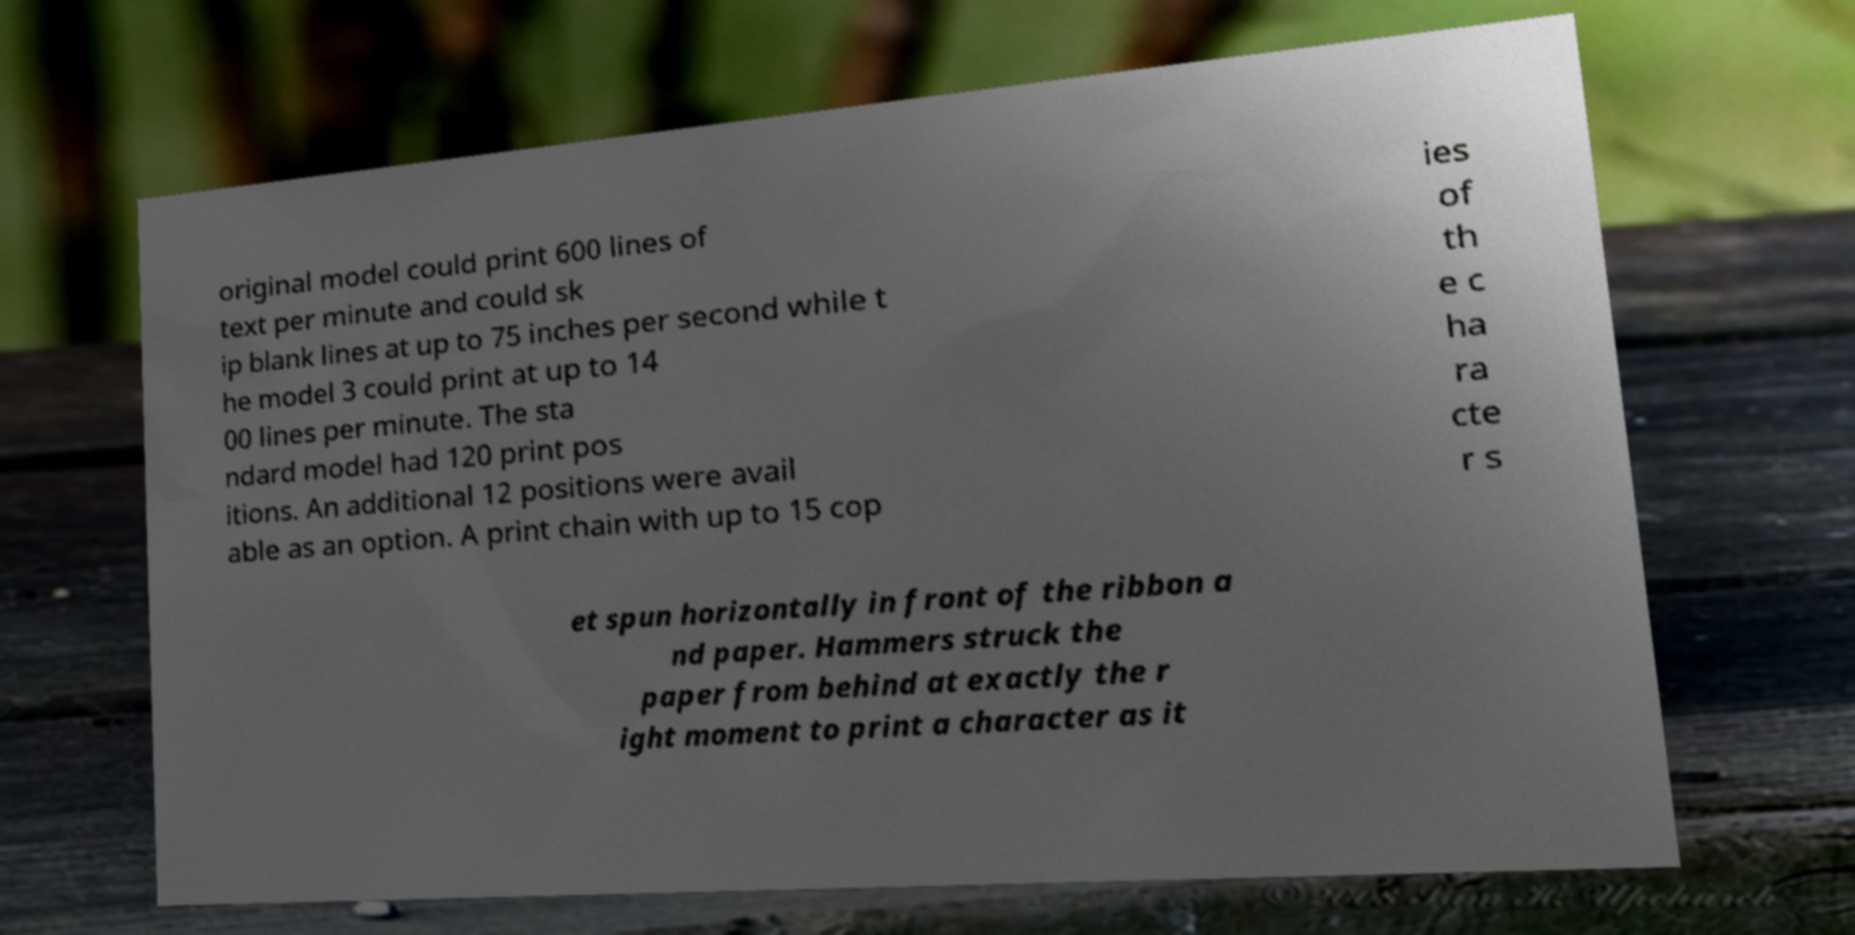For documentation purposes, I need the text within this image transcribed. Could you provide that? original model could print 600 lines of text per minute and could sk ip blank lines at up to 75 inches per second while t he model 3 could print at up to 14 00 lines per minute. The sta ndard model had 120 print pos itions. An additional 12 positions were avail able as an option. A print chain with up to 15 cop ies of th e c ha ra cte r s et spun horizontally in front of the ribbon a nd paper. Hammers struck the paper from behind at exactly the r ight moment to print a character as it 